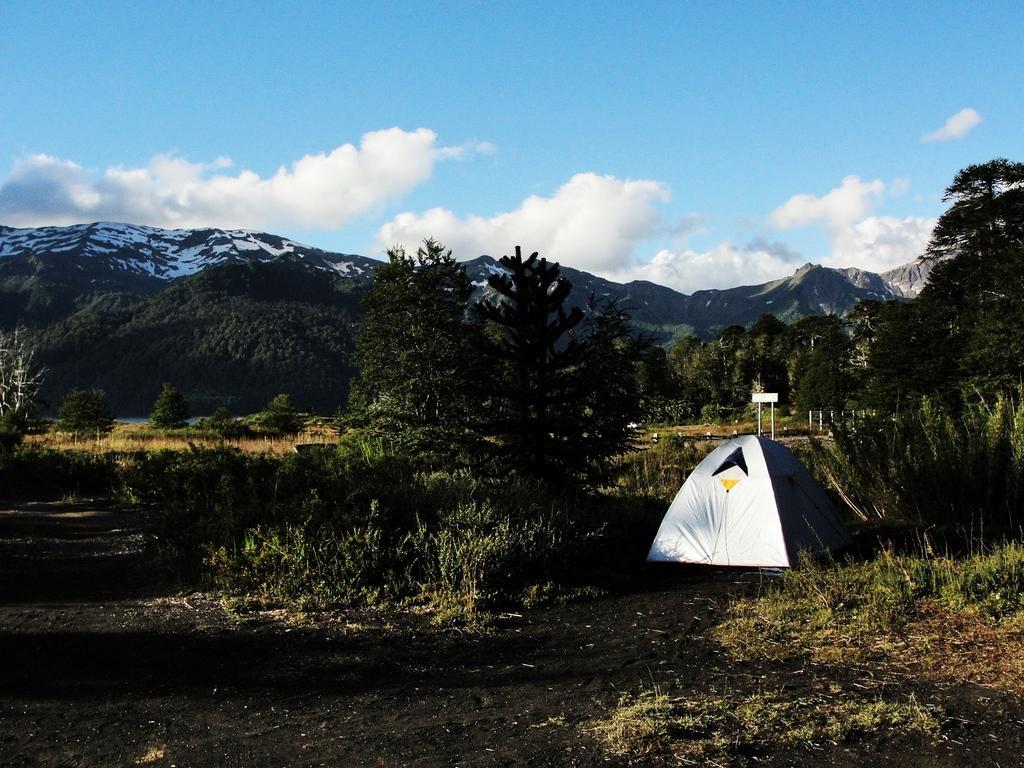How would you summarize this image in a sentence or two? At the bottom of the image on the ground there is grass and also there are small plants. In the middle of them there is a camping tent. Behind that there are trees. In the background there are hills. At the top of the image there is sky. 